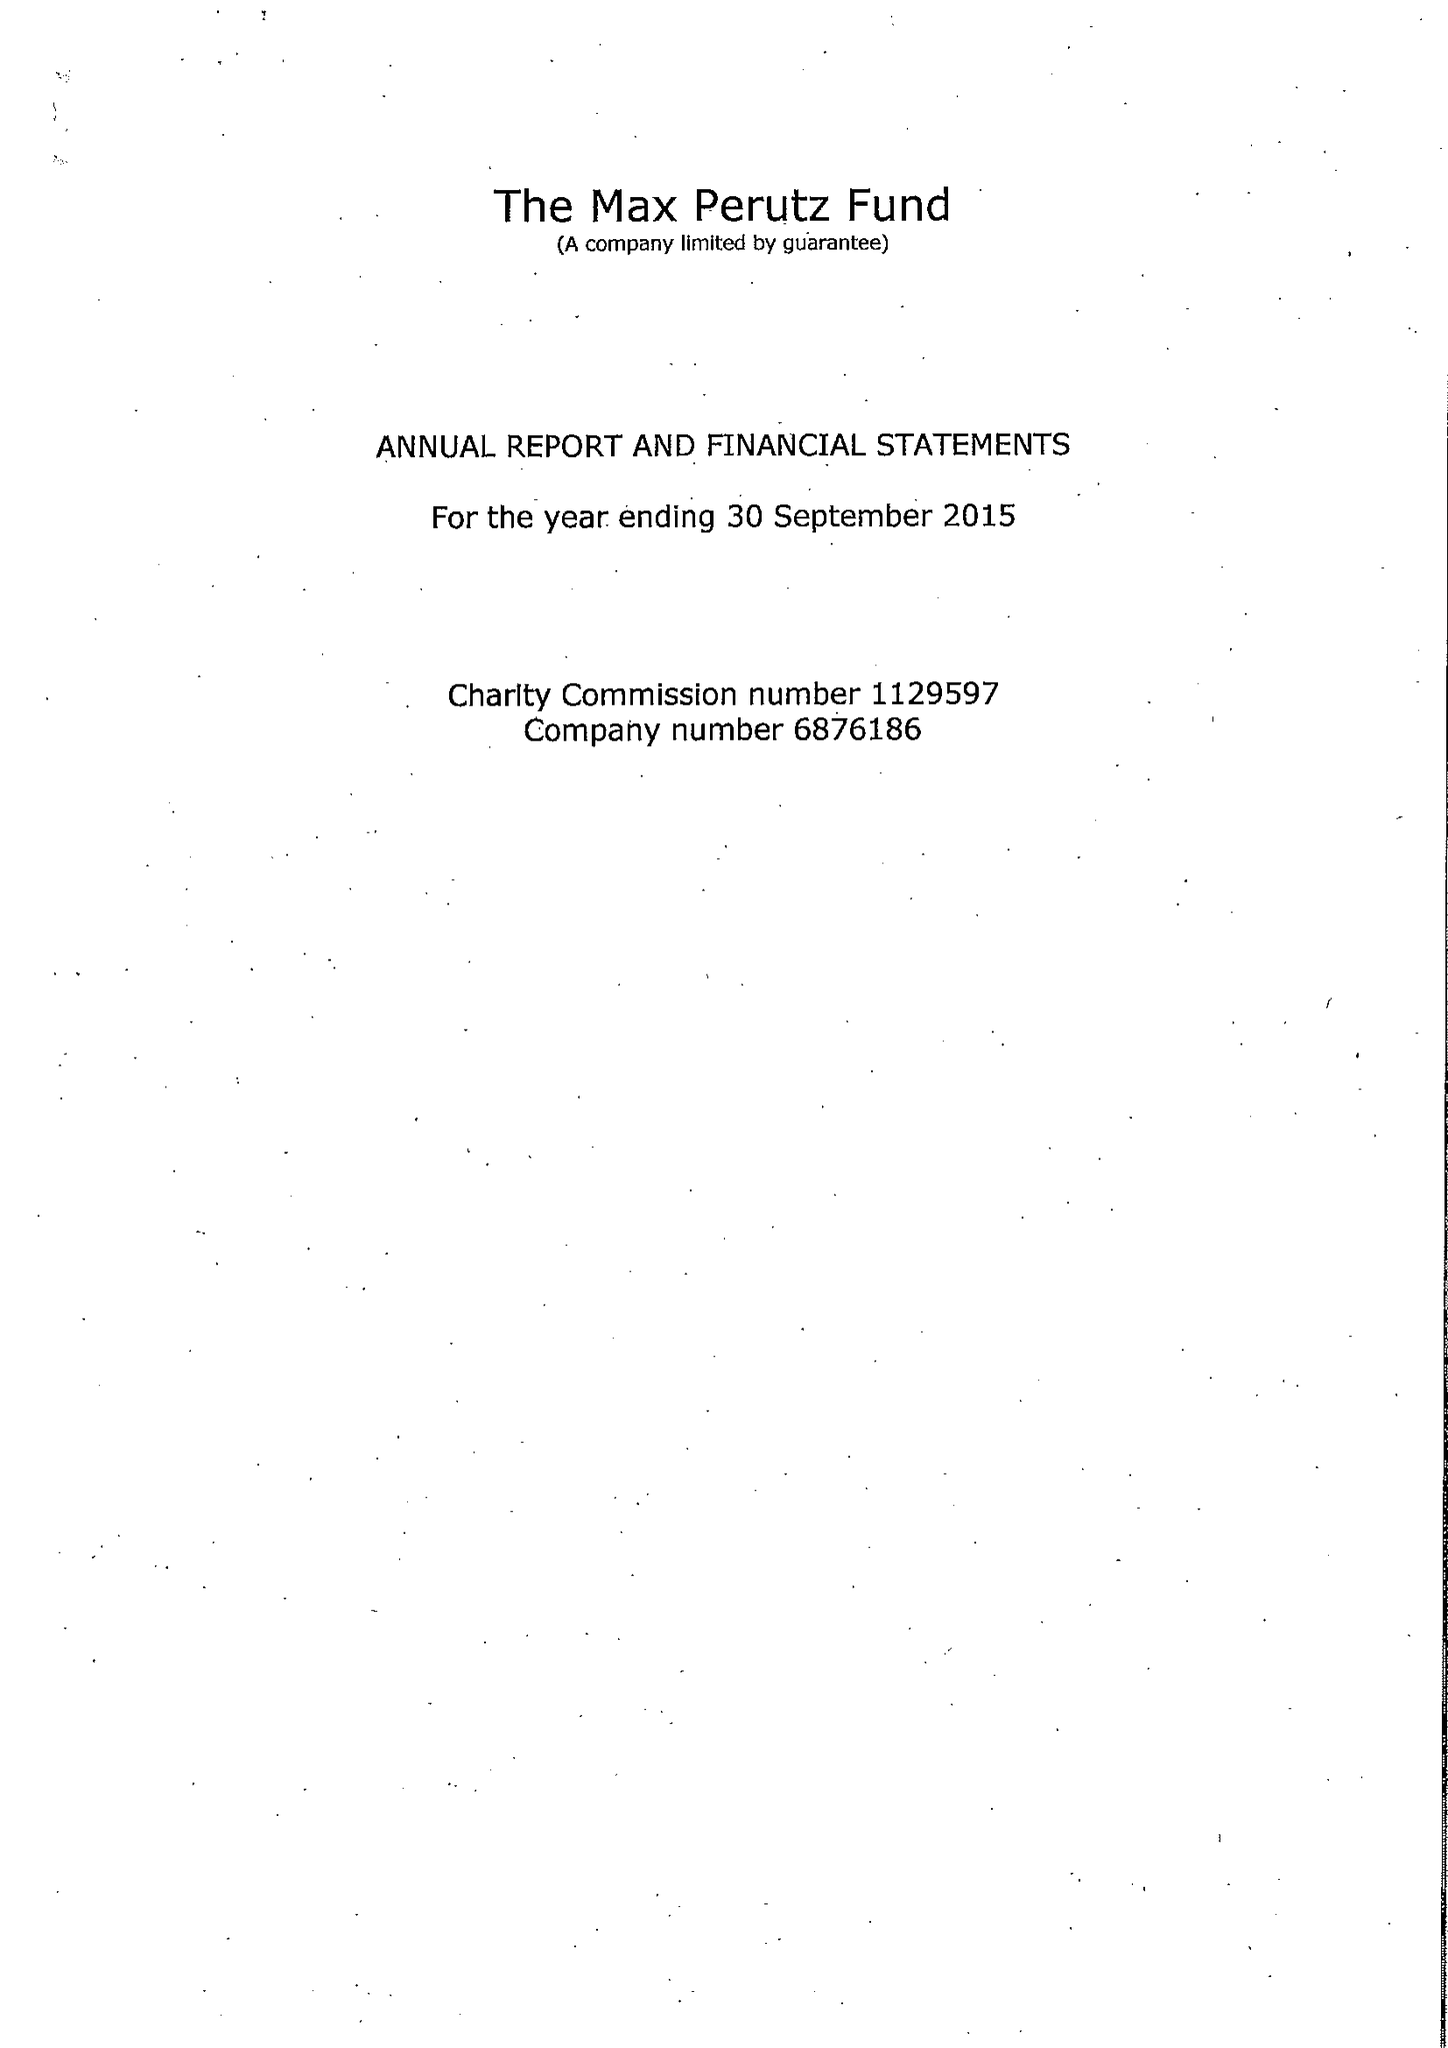What is the value for the report_date?
Answer the question using a single word or phrase. 2015-09-30 